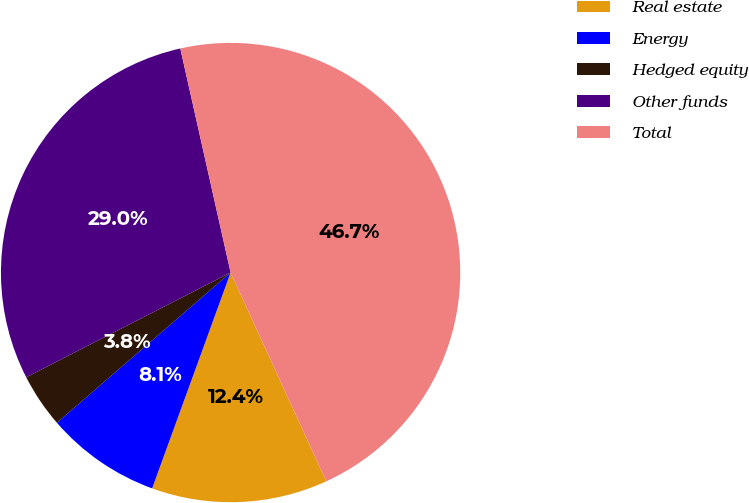<chart> <loc_0><loc_0><loc_500><loc_500><pie_chart><fcel>Real estate<fcel>Energy<fcel>Hedged equity<fcel>Other funds<fcel>Total<nl><fcel>12.39%<fcel>8.1%<fcel>3.81%<fcel>29.02%<fcel>46.67%<nl></chart> 